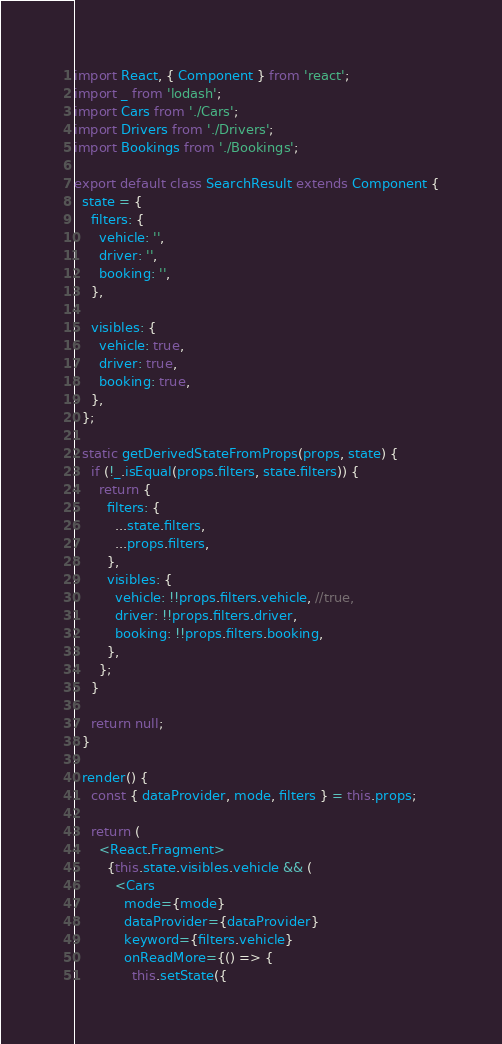Convert code to text. <code><loc_0><loc_0><loc_500><loc_500><_JavaScript_>import React, { Component } from 'react';
import _ from 'lodash';
import Cars from './Cars';
import Drivers from './Drivers';
import Bookings from './Bookings';

export default class SearchResult extends Component {
  state = {
    filters: {
      vehicle: '',
      driver: '',
      booking: '',
    },

    visibles: {
      vehicle: true,
      driver: true,
      booking: true,
    },
  };

  static getDerivedStateFromProps(props, state) {
    if (!_.isEqual(props.filters, state.filters)) {
      return {
        filters: {
          ...state.filters,
          ...props.filters,
        },
        visibles: {
          vehicle: !!props.filters.vehicle, //true,
          driver: !!props.filters.driver,
          booking: !!props.filters.booking,
        },
      };
    }

    return null;
  }

  render() {
    const { dataProvider, mode, filters } = this.props;

    return (
      <React.Fragment>
        {this.state.visibles.vehicle && (
          <Cars
            mode={mode}
            dataProvider={dataProvider}
            keyword={filters.vehicle}
            onReadMore={() => {
              this.setState({</code> 